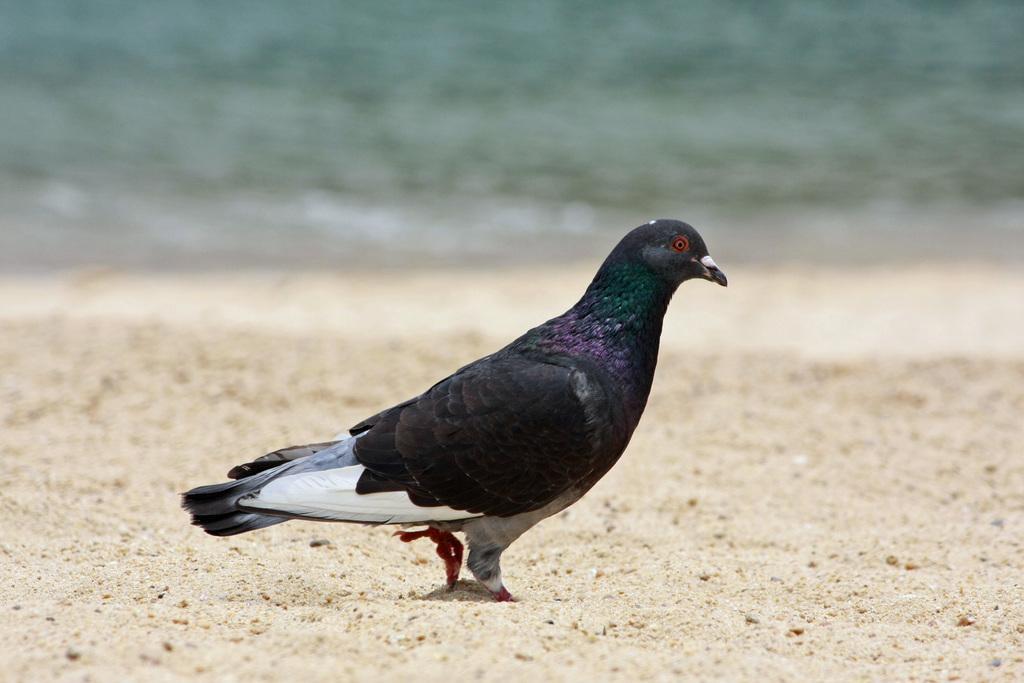Can you describe this image briefly? In this picture I can see there is a pigeon and walking on the sand and in the backdrop I can see there is a ocean. 